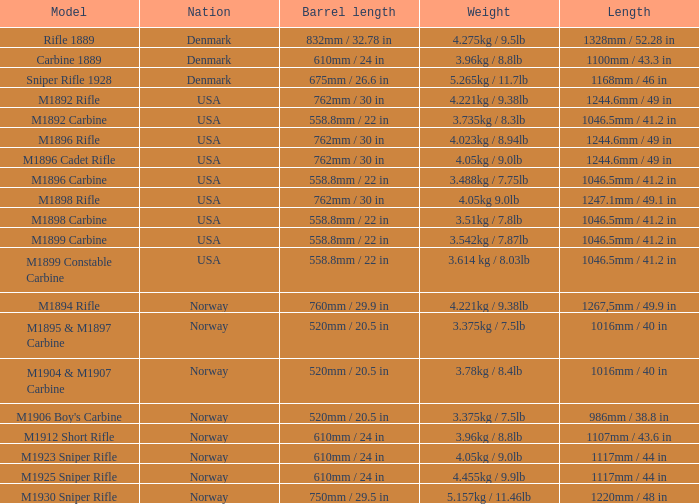What is Nation, when Model is M1895 & M1897 Carbine? Norway. 